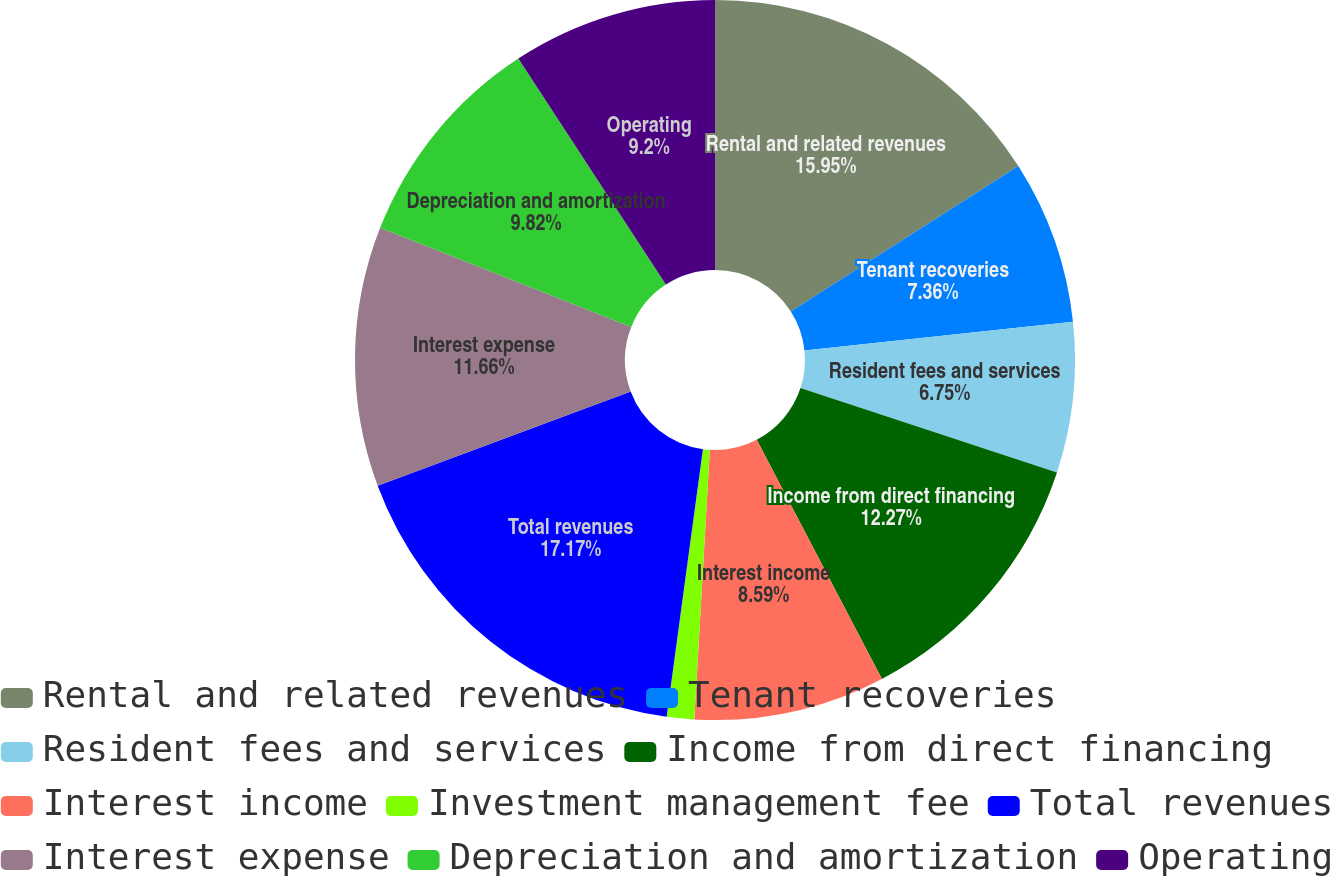<chart> <loc_0><loc_0><loc_500><loc_500><pie_chart><fcel>Rental and related revenues<fcel>Tenant recoveries<fcel>Resident fees and services<fcel>Income from direct financing<fcel>Interest income<fcel>Investment management fee<fcel>Total revenues<fcel>Interest expense<fcel>Depreciation and amortization<fcel>Operating<nl><fcel>15.95%<fcel>7.36%<fcel>6.75%<fcel>12.27%<fcel>8.59%<fcel>1.23%<fcel>17.18%<fcel>11.66%<fcel>9.82%<fcel>9.2%<nl></chart> 